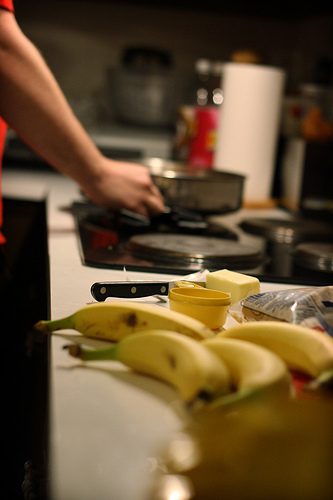Is the person to the right of the pot in the center of the picture? No, the person is not to the right of the pot nor in the center; they appear more towards the left side, aligning with the kitchen elements. 